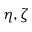<formula> <loc_0><loc_0><loc_500><loc_500>\eta , \zeta</formula> 